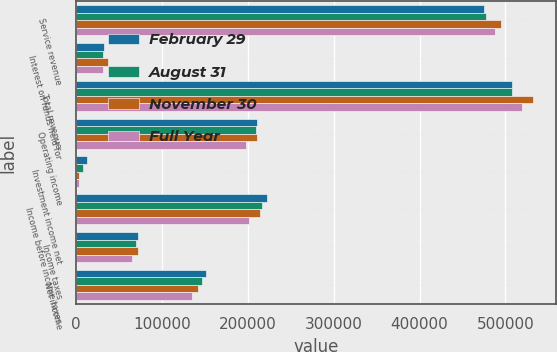Convert chart to OTSL. <chart><loc_0><loc_0><loc_500><loc_500><stacked_bar_chart><ecel><fcel>Service revenue<fcel>Interest on funds held for<fcel>Total revenue<fcel>Operating income<fcel>Investment income net<fcel>Income before income taxes<fcel>Income taxes<fcel>Net income<nl><fcel>February 29<fcel>474815<fcel>32315<fcel>507130<fcel>210588<fcel>12237<fcel>222825<fcel>71750<fcel>151075<nl><fcel>August 31<fcel>477039<fcel>30754<fcel>507793<fcel>209476<fcel>7503<fcel>216979<fcel>69867<fcel>147112<nl><fcel>November 30<fcel>494845<fcel>37327<fcel>532172<fcel>210399<fcel>3597<fcel>213996<fcel>71522<fcel>142474<nl><fcel>Full Year<fcel>487837<fcel>31391<fcel>519228<fcel>197804<fcel>3211<fcel>201015<fcel>65531<fcel>135484<nl></chart> 